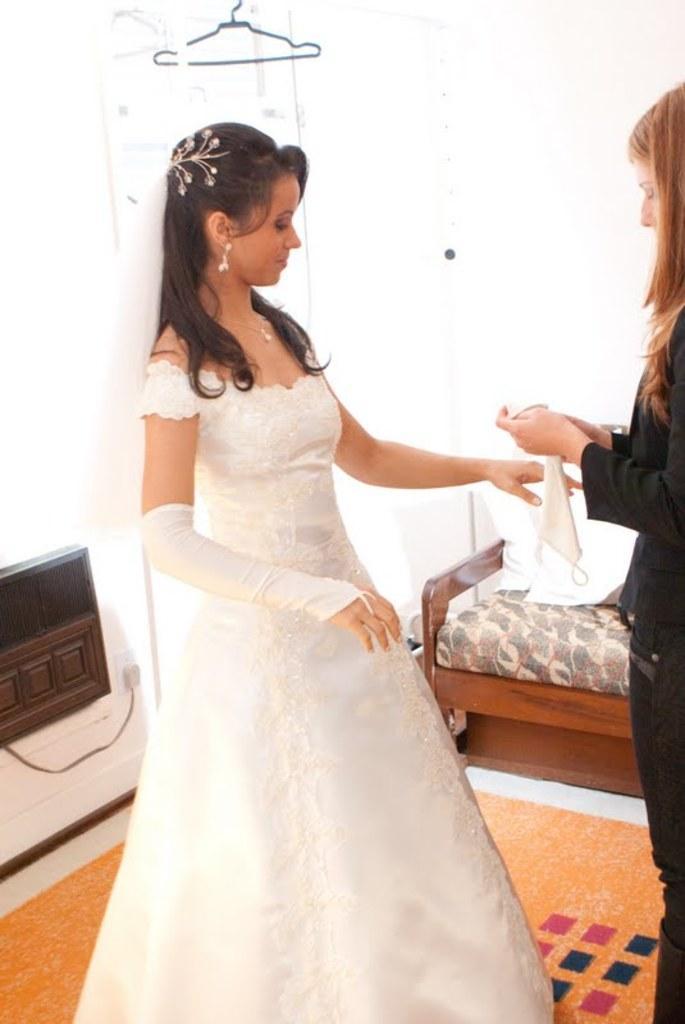Can you describe this image briefly? There are two persons standing in this image. The woman in the center is wearing a white colour bridal dress. In the background there is a bench, floor mat on the floor. 